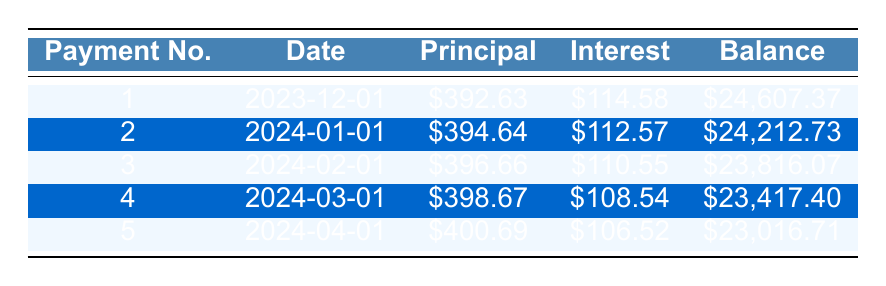What is the total loan amount? The loan amount is specified in the loan details section of the table, which states that the loan amount is $25,000.
Answer: 25000 What is the monthly payment amount? The monthly payment amount is also included in the loan details, showing that it is $478.30.
Answer: 478.30 How much principal is paid in the first month? The first month’s principal payment is listed in the amortization schedule under the first payment, which is $392.63.
Answer: 392.63 What is the interest payment for the second month? The interest payment for the second month is shown in the amortization schedule under the second entry, which indicates that it is $112.57.
Answer: 112.57 What is the remaining balance after the third payment? The remaining balance after the third payment can be found in the amortization schedule under the third payment, which is $23,816.07.
Answer: 23816.07 How much total principal has been paid after the first five payments? To calculate the total principal paid after the first five payments, we add the principal payments of each month: $392.63 + $394.64 + $396.66 + $398.67 + $400.69 = $1982.29.
Answer: 1982.29 Is the interest payment decreasing over the first five months? Yes, by looking at the interest payments listed for each of the five months, we can see they decline from $114.58 in the first month to $106.52 in the fifth month, confirming a downward trend.
Answer: Yes What is the difference between the first principal payment and the last? To find the difference, subtract the last principal payment from the first: $392.63 (first month) - $400.69 (fifth month) = -$8.06, indicating that the last principal payment is higher.
Answer: -8.06 Which month has the highest principal payment? By observing the principal payments in the table, we see that the fifth month's payment of $400.69 is the highest among the five entries.
Answer: Fifth month What is the total interest paid after the first five payments? To calculate the total interest paid, sum the interest payments for the first five payments: $114.58 + $112.57 + $110.55 + $108.54 + $106.52 = $552.76.
Answer: 552.76 